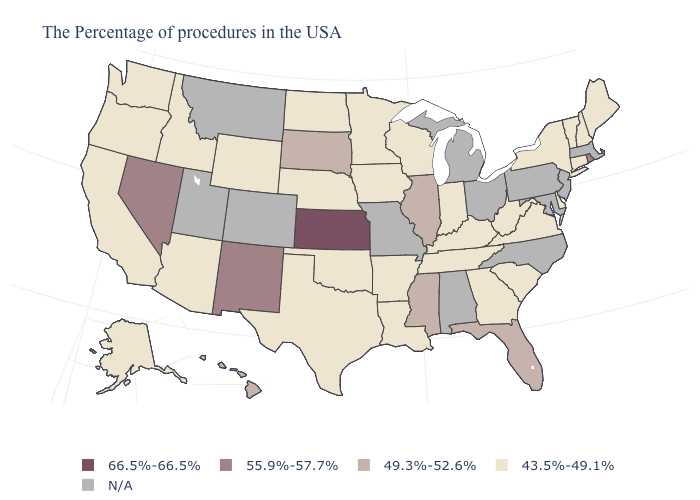What is the highest value in the West ?
Write a very short answer. 55.9%-57.7%. What is the value of Washington?
Give a very brief answer. 43.5%-49.1%. Which states have the lowest value in the USA?
Give a very brief answer. Maine, New Hampshire, Vermont, Connecticut, New York, Delaware, Virginia, South Carolina, West Virginia, Georgia, Kentucky, Indiana, Tennessee, Wisconsin, Louisiana, Arkansas, Minnesota, Iowa, Nebraska, Oklahoma, Texas, North Dakota, Wyoming, Arizona, Idaho, California, Washington, Oregon, Alaska. Does Illinois have the lowest value in the MidWest?
Keep it brief. No. Name the states that have a value in the range 66.5%-66.5%?
Answer briefly. Kansas. What is the value of New Hampshire?
Quick response, please. 43.5%-49.1%. Does Rhode Island have the highest value in the Northeast?
Write a very short answer. Yes. What is the value of Virginia?
Short answer required. 43.5%-49.1%. What is the highest value in the USA?
Keep it brief. 66.5%-66.5%. Name the states that have a value in the range N/A?
Give a very brief answer. Massachusetts, New Jersey, Maryland, Pennsylvania, North Carolina, Ohio, Michigan, Alabama, Missouri, Colorado, Utah, Montana. What is the value of South Dakota?
Be succinct. 49.3%-52.6%. What is the lowest value in the South?
Give a very brief answer. 43.5%-49.1%. What is the value of Ohio?
Quick response, please. N/A. What is the value of Montana?
Give a very brief answer. N/A. Does the first symbol in the legend represent the smallest category?
Give a very brief answer. No. 